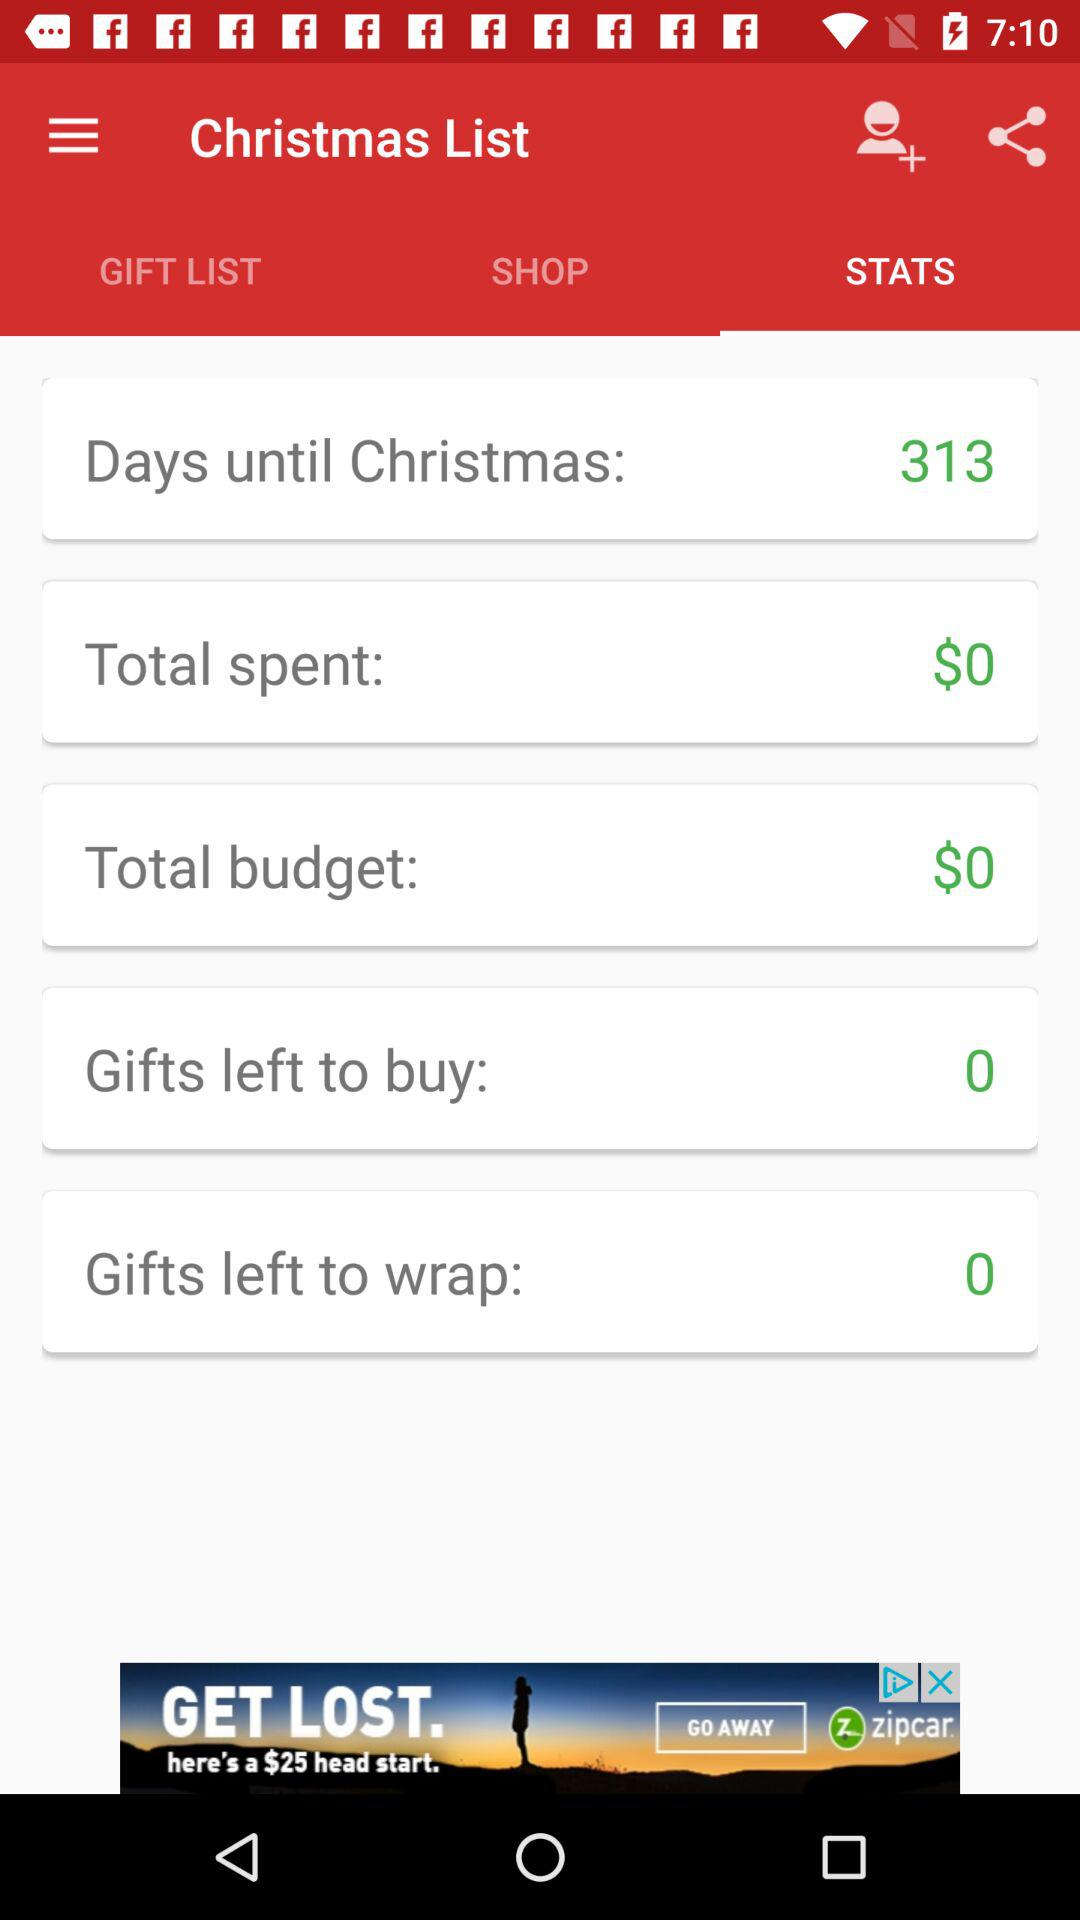What is the total spent amount? The total spent amount is $0. 